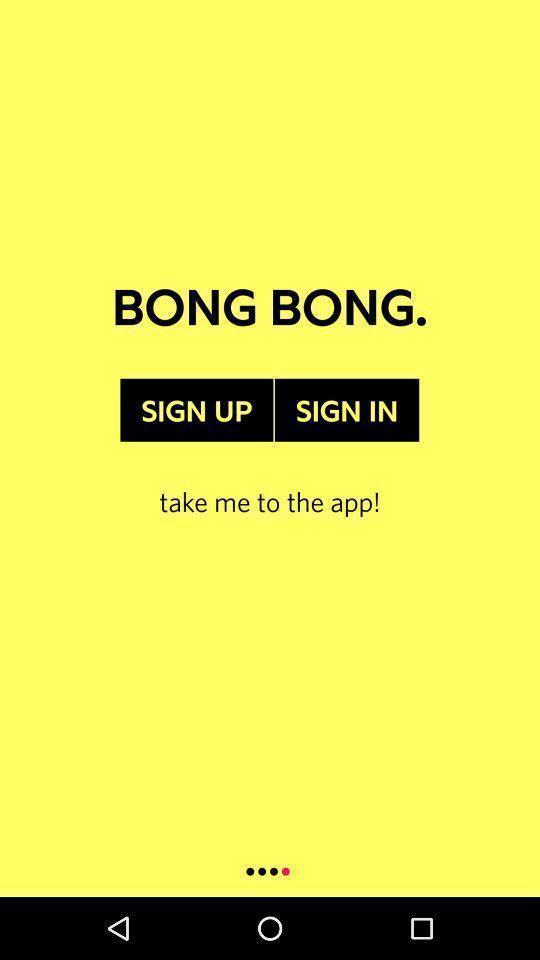What can you discern from this picture? Welcome page of a music application. 